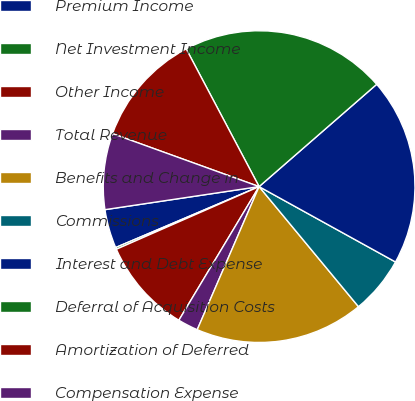Convert chart to OTSL. <chart><loc_0><loc_0><loc_500><loc_500><pie_chart><fcel>Premium Income<fcel>Net Investment Income<fcel>Other Income<fcel>Total Revenue<fcel>Benefits and Change in<fcel>Commissions<fcel>Interest and Debt Expense<fcel>Deferral of Acquisition Costs<fcel>Amortization of Deferred<fcel>Compensation Expense<nl><fcel>4.03%<fcel>0.19%<fcel>9.81%<fcel>2.11%<fcel>17.5%<fcel>5.96%<fcel>19.43%<fcel>21.35%<fcel>11.73%<fcel>7.88%<nl></chart> 